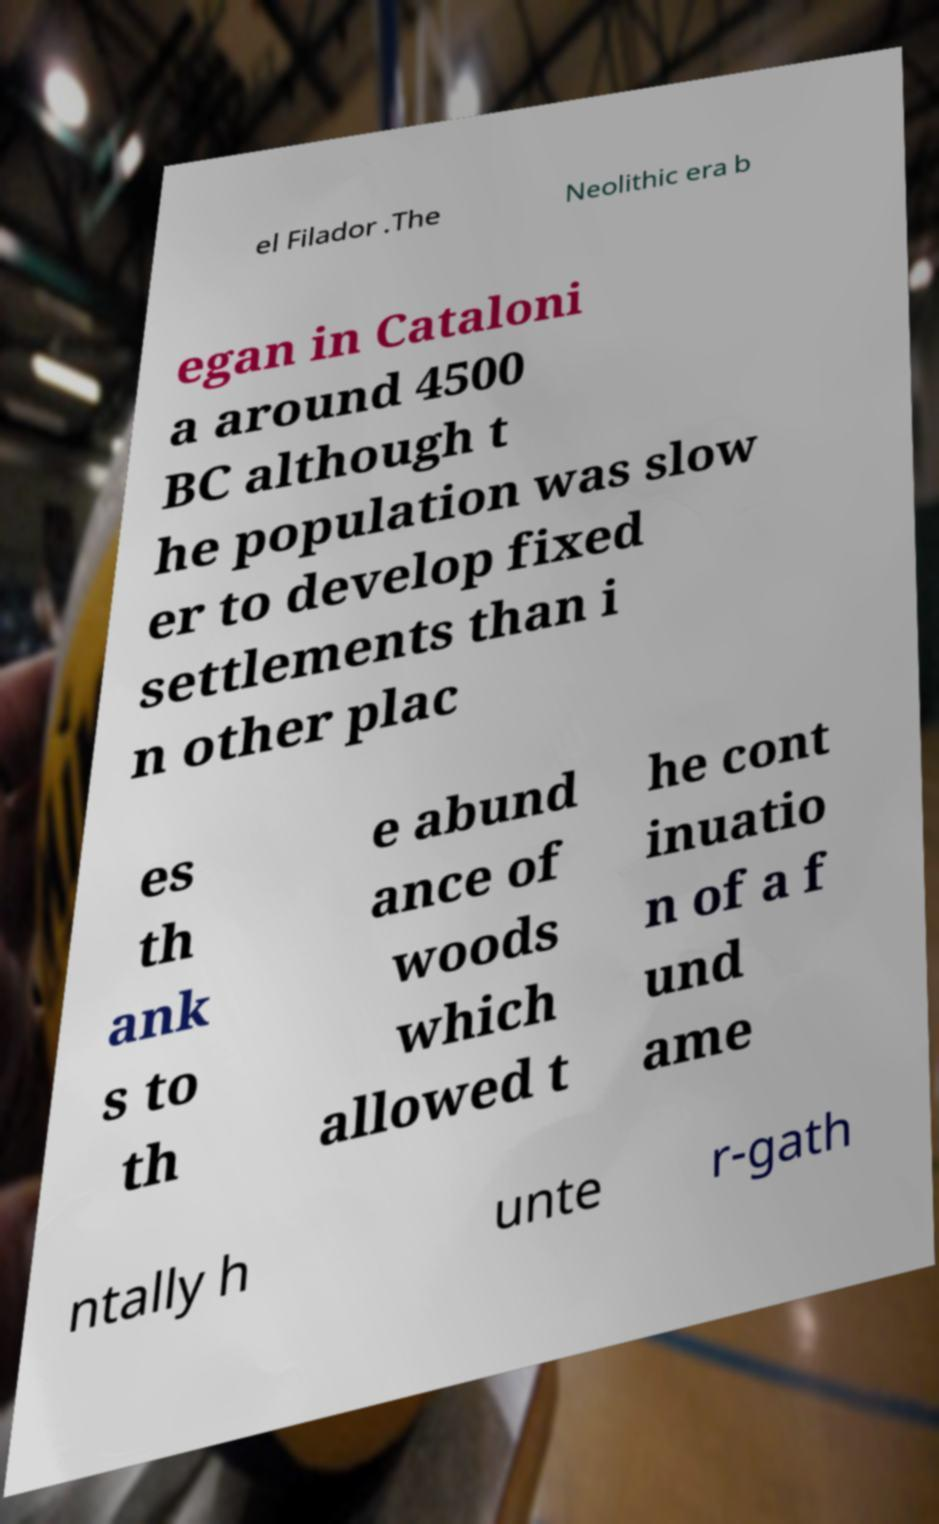Could you assist in decoding the text presented in this image and type it out clearly? el Filador .The Neolithic era b egan in Cataloni a around 4500 BC although t he population was slow er to develop fixed settlements than i n other plac es th ank s to th e abund ance of woods which allowed t he cont inuatio n of a f und ame ntally h unte r-gath 